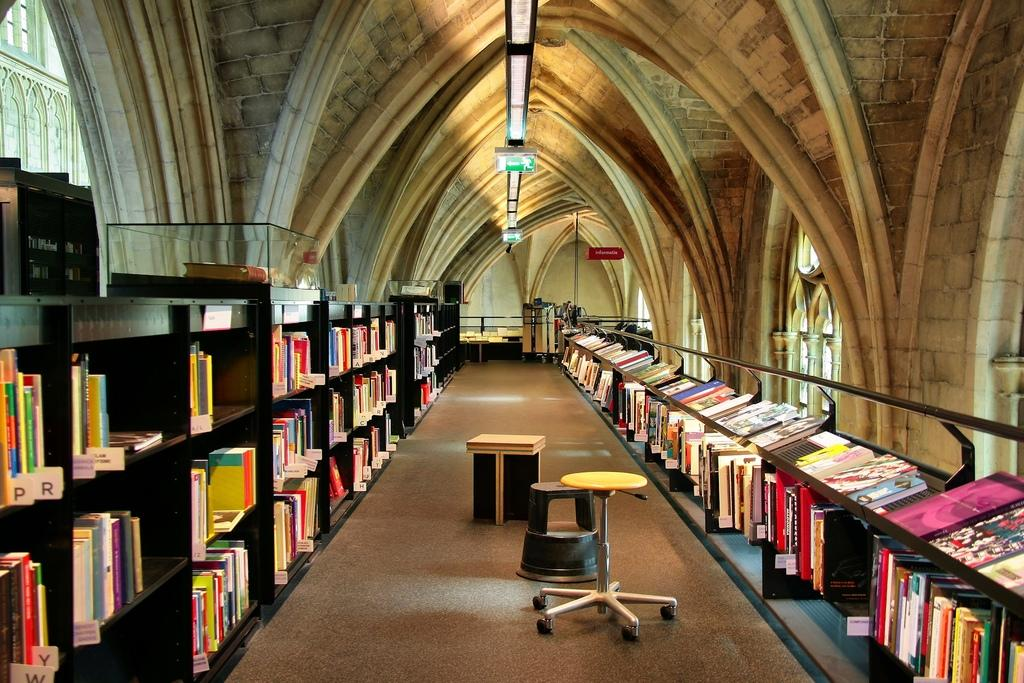What type of furniture is present in the image? There are book shelves, a table, and a stool in the image. What can be found on the book shelves? The book shelves contain a number of books. Are there any lighting fixtures visible in the image? Yes, there are lights visible in the image. What architectural style is displayed in the image? The image displays a different architecture. Can you tell me how many bombs are on the table in the image? There are no bombs present in the image; the table contains a stool and is likely used for other purposes. Is your aunt visible in the image? There is no mention of an aunt in the provided facts, and no person is visible in the image. 